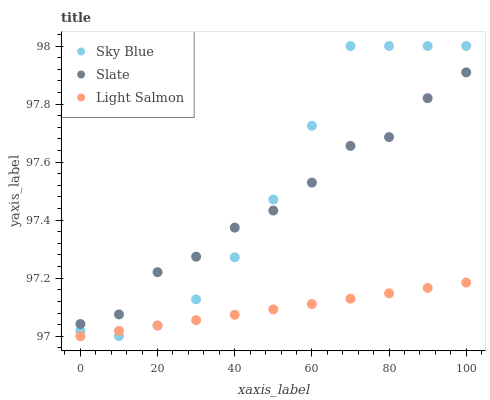Does Light Salmon have the minimum area under the curve?
Answer yes or no. Yes. Does Sky Blue have the maximum area under the curve?
Answer yes or no. Yes. Does Slate have the minimum area under the curve?
Answer yes or no. No. Does Slate have the maximum area under the curve?
Answer yes or no. No. Is Light Salmon the smoothest?
Answer yes or no. Yes. Is Slate the roughest?
Answer yes or no. Yes. Is Slate the smoothest?
Answer yes or no. No. Is Light Salmon the roughest?
Answer yes or no. No. Does Light Salmon have the lowest value?
Answer yes or no. Yes. Does Slate have the lowest value?
Answer yes or no. No. Does Sky Blue have the highest value?
Answer yes or no. Yes. Does Slate have the highest value?
Answer yes or no. No. Is Light Salmon less than Slate?
Answer yes or no. Yes. Is Slate greater than Light Salmon?
Answer yes or no. Yes. Does Sky Blue intersect Slate?
Answer yes or no. Yes. Is Sky Blue less than Slate?
Answer yes or no. No. Is Sky Blue greater than Slate?
Answer yes or no. No. Does Light Salmon intersect Slate?
Answer yes or no. No. 